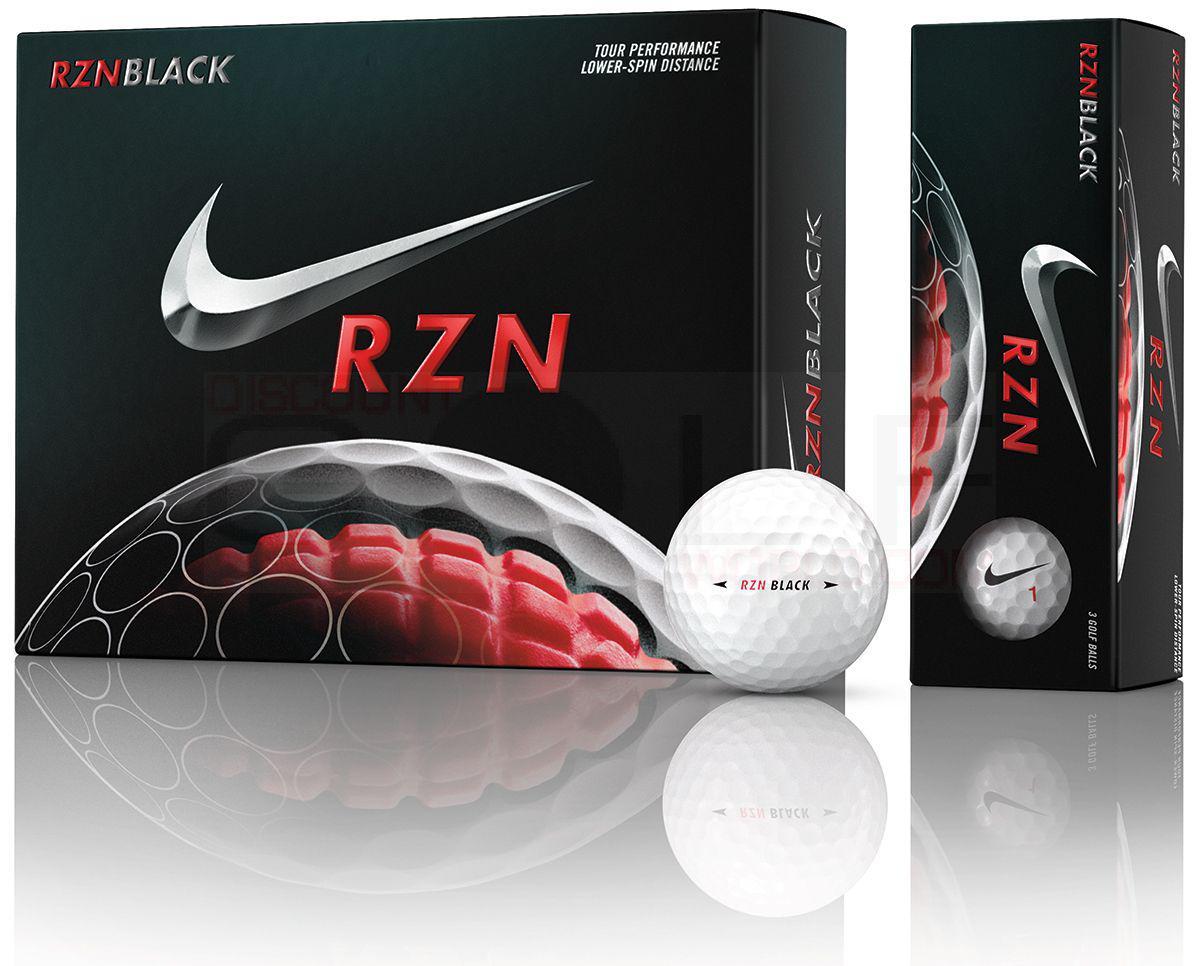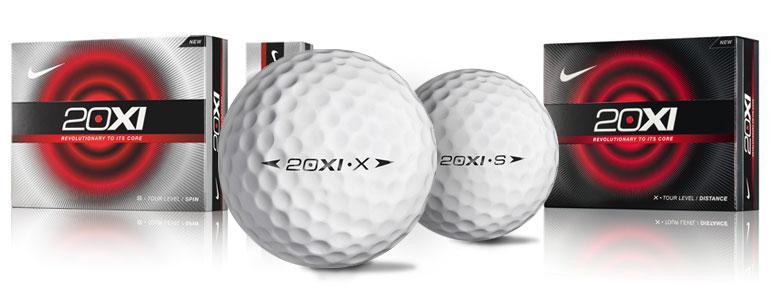The first image is the image on the left, the second image is the image on the right. Analyze the images presented: Is the assertion "In at least one image there are two black boxes that have silver and red on them." valid? Answer yes or no. Yes. The first image is the image on the left, the second image is the image on the right. Examine the images to the left and right. Is the description "There are exactly three golf balls that aren't in a box." accurate? Answer yes or no. Yes. 